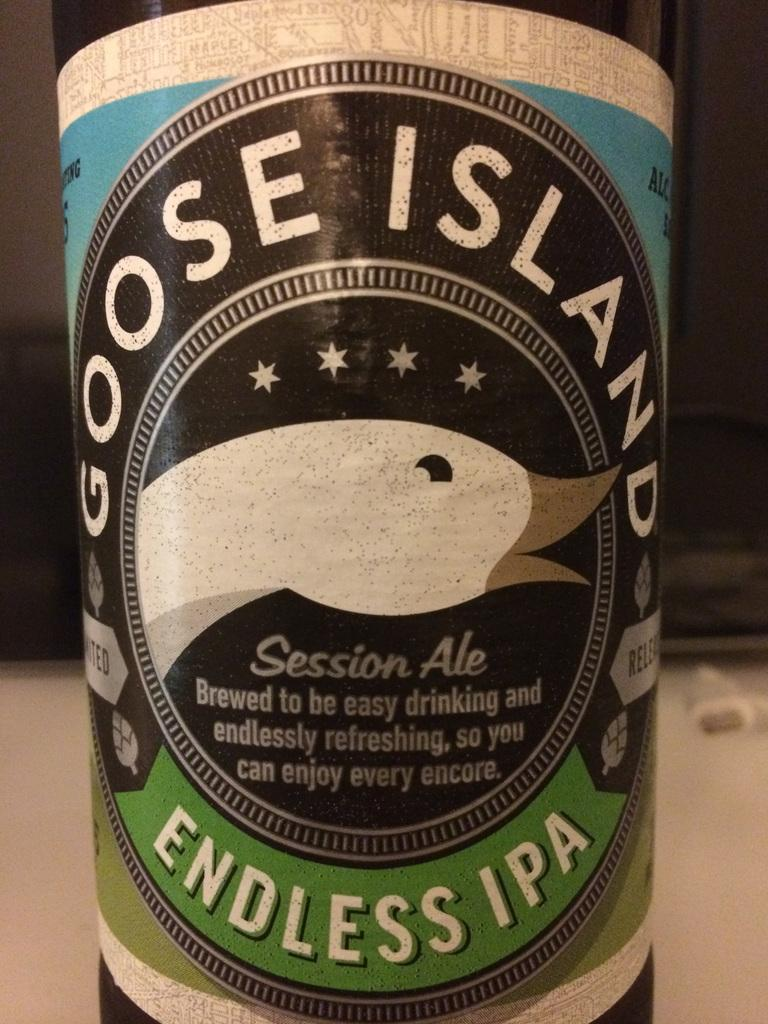Provide a one-sentence caption for the provided image. A large bottle of Goose Island Endless IPA with a duck on the label. 